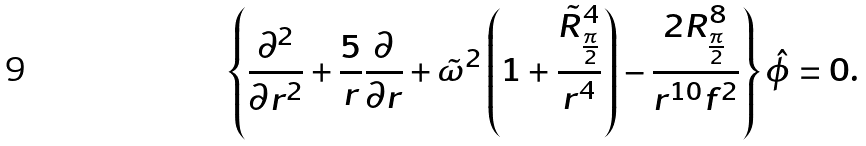Convert formula to latex. <formula><loc_0><loc_0><loc_500><loc_500>\left \{ { \frac { \partial ^ { 2 } } { \partial r ^ { 2 } } } + { \frac { 5 } { r } } { \frac { \partial } { \partial r } } + \tilde { \omega } ^ { 2 } \left ( 1 + { \frac { \tilde { R } _ { \frac { \pi } { 2 } } ^ { 4 } } { r ^ { 4 } } } \right ) - { \frac { 2 R _ { \frac { \pi } { 2 } } ^ { 8 } } { r ^ { 1 0 } f ^ { 2 } } } \right \} \hat { \phi } = 0 .</formula> 